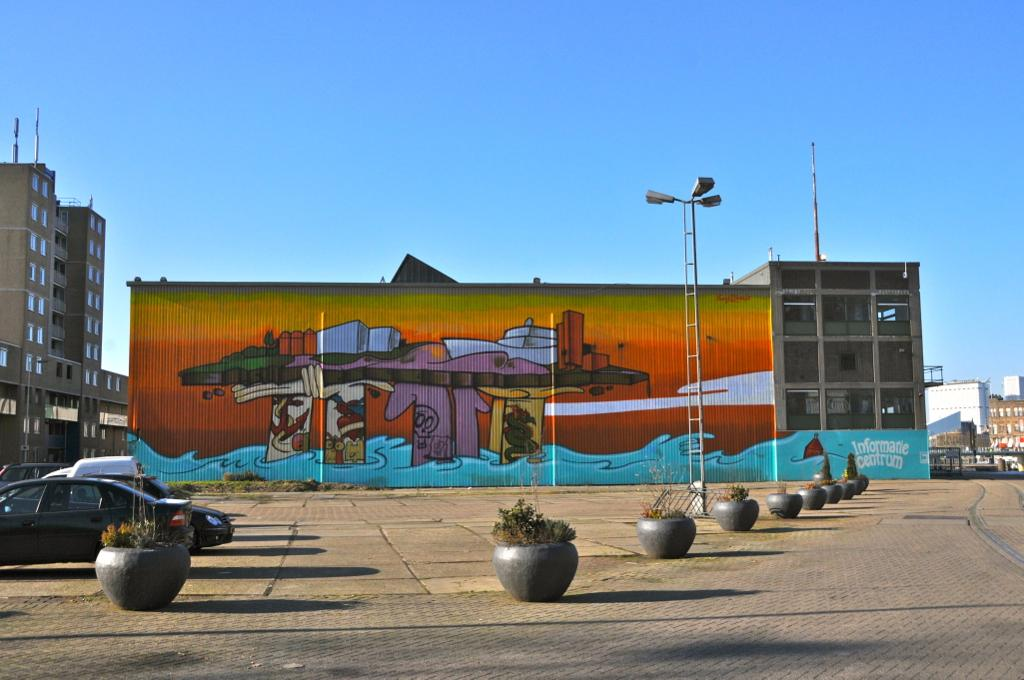What type of structures can be seen in the image? There are buildings in the image. What else can be seen in the image besides buildings? There are poles, lights, cars, plants, and the sky visible in the image. What might be used for illumination in the image? Lights can be seen in the image. What type of transportation is present in the image? Cars are present in the image. What type of vegetation is visible in the image? Plants are visible in the image. Can you help me find the office in the image? There is no office present in the image. What type of burn can be seen on the plants in the image? There is no burn visible on the plants in the image; they appear to be healthy. 